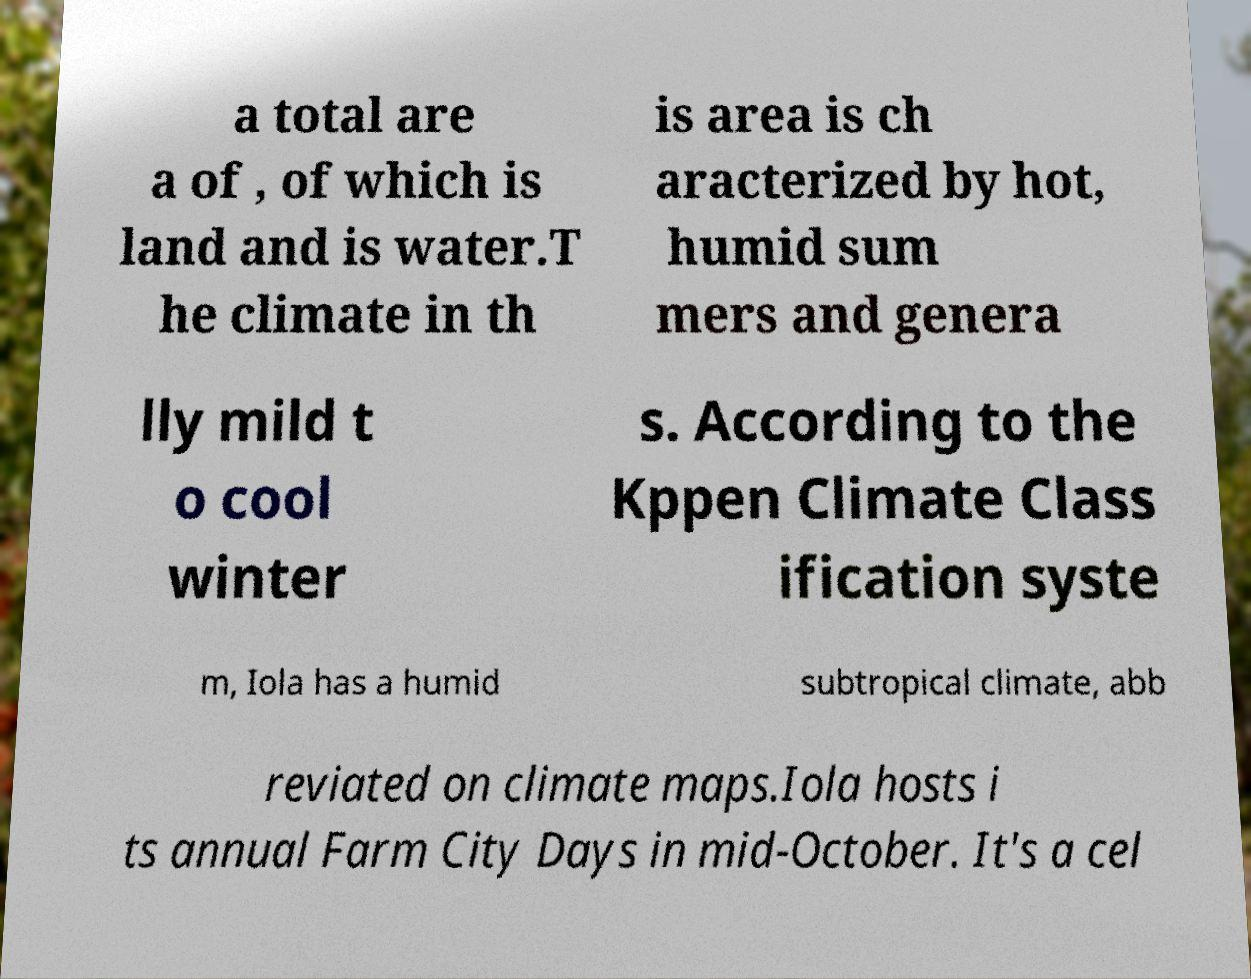For documentation purposes, I need the text within this image transcribed. Could you provide that? a total are a of , of which is land and is water.T he climate in th is area is ch aracterized by hot, humid sum mers and genera lly mild t o cool winter s. According to the Kppen Climate Class ification syste m, Iola has a humid subtropical climate, abb reviated on climate maps.Iola hosts i ts annual Farm City Days in mid-October. It's a cel 